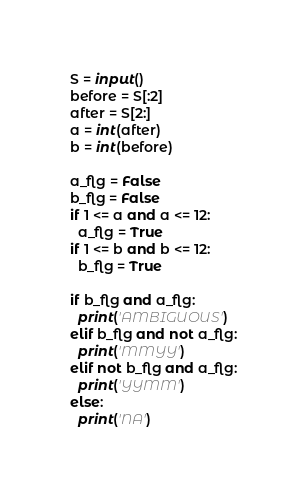Convert code to text. <code><loc_0><loc_0><loc_500><loc_500><_Python_>S = input()
before = S[:2]
after = S[2:]
a = int(after)
b = int(before)

a_flg = False
b_flg = False
if 1 <= a and a <= 12:
  a_flg = True
if 1 <= b and b <= 12:
  b_flg = True

if b_flg and a_flg:
  print('AMBIGUOUS')
elif b_flg and not a_flg:
  print('MMYY')
elif not b_flg and a_flg:
  print('YYMM')
else:
  print('NA')</code> 